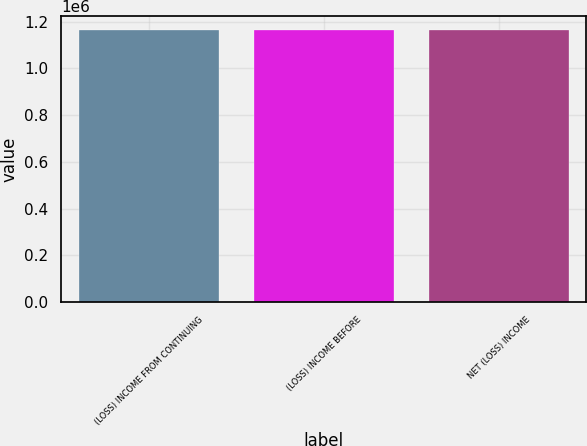Convert chart to OTSL. <chart><loc_0><loc_0><loc_500><loc_500><bar_chart><fcel>(LOSS) INCOME FROM CONTINUING<fcel>(LOSS) INCOME BEFORE<fcel>NET (LOSS) INCOME<nl><fcel>1.16354e+06<fcel>1.16459e+06<fcel>1.16565e+06<nl></chart> 